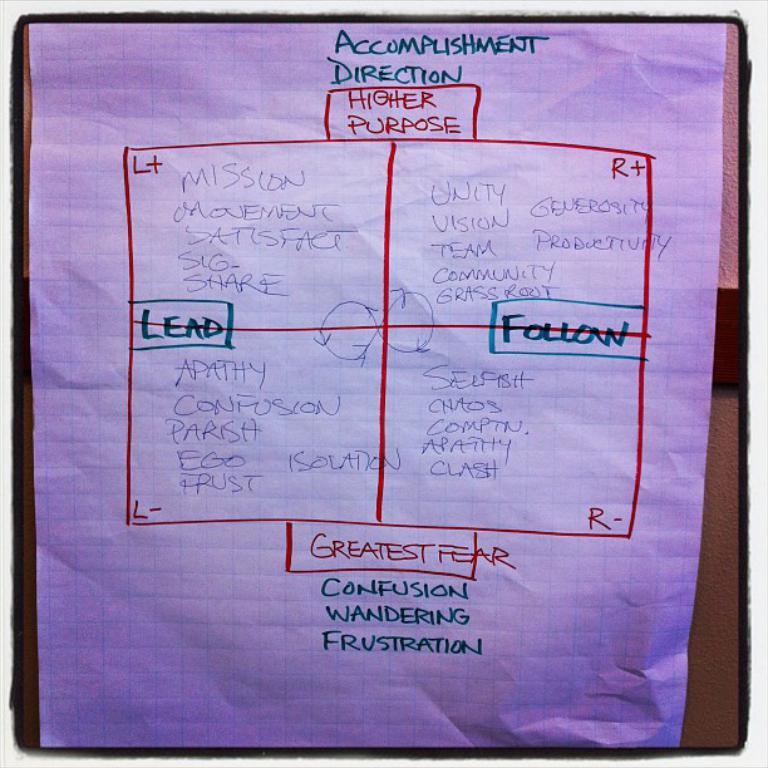What is one of the greatest fear?
Ensure brevity in your answer.  Confusion. 